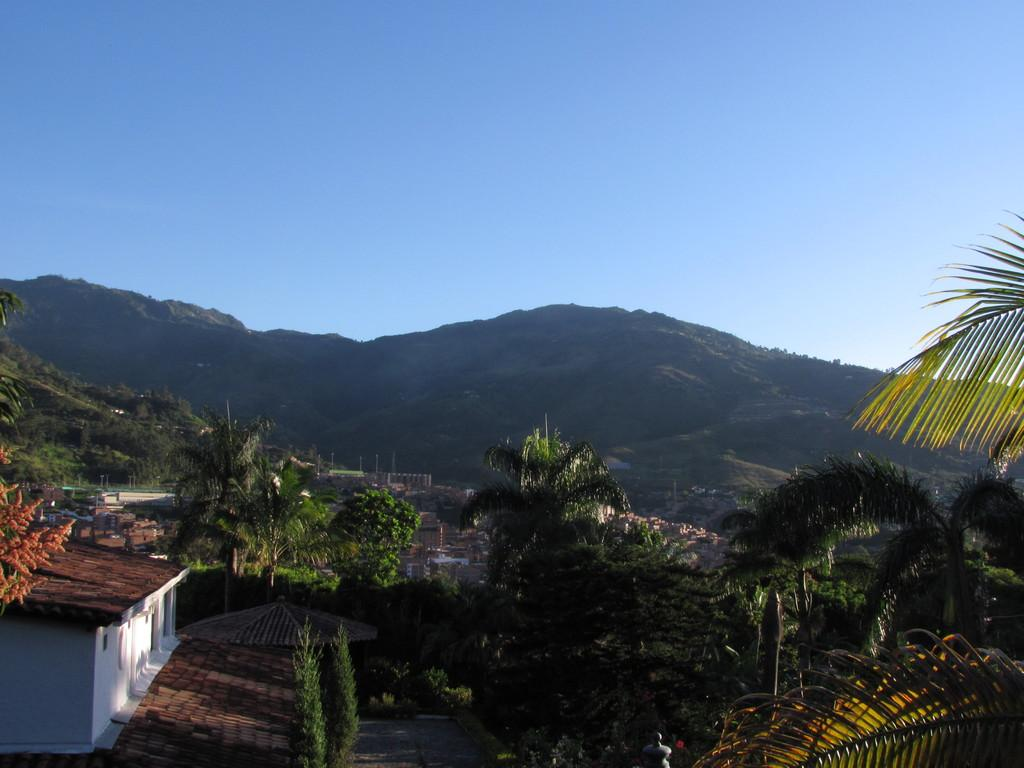What structure is located on the left side of the image? There is a house on the left side of the image. What can be seen in the middle of the image? There are trees in the middle of the image. What type of landscape feature is visible at the back side of the image? There is a hill visible at the back side of the image. What is visible at the top of the image? The sky is visible at the top of the image. Can you see any toes on the trees in the image? There are no toes present on the trees in the image; trees do not have toes. What type of animal is standing on the hill in the image? There are no animals visible on the hill in the image. Whose head can be seen in the sky in the image? There are no heads visible in the sky in the image. 